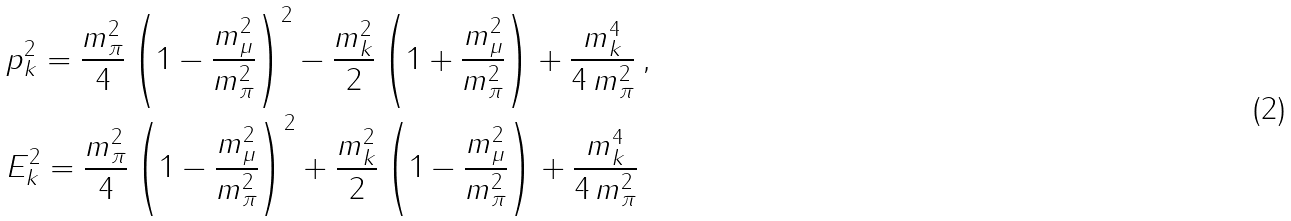<formula> <loc_0><loc_0><loc_500><loc_500>\null & \null p _ { k } ^ { 2 } = \frac { m _ { \pi } ^ { 2 } } { 4 } \left ( 1 - \frac { m _ { \mu } ^ { 2 } } { m _ { \pi } ^ { 2 } } \right ) ^ { 2 } - \frac { m _ { k } ^ { 2 } } { 2 } \left ( 1 + \frac { m _ { \mu } ^ { 2 } } { m _ { \pi } ^ { 2 } } \right ) + \frac { m _ { k } ^ { 4 } } { 4 \, m _ { \pi } ^ { 2 } } \, , \\ \null & \null E _ { k } ^ { 2 } = \frac { m _ { \pi } ^ { 2 } } { 4 } \left ( 1 - \frac { m _ { \mu } ^ { 2 } } { m _ { \pi } ^ { 2 } } \right ) ^ { 2 } + \frac { m _ { k } ^ { 2 } } { 2 } \left ( 1 - \frac { m _ { \mu } ^ { 2 } } { m _ { \pi } ^ { 2 } } \right ) + \frac { m _ { k } ^ { 4 } } { 4 \, m _ { \pi } ^ { 2 } }</formula> 